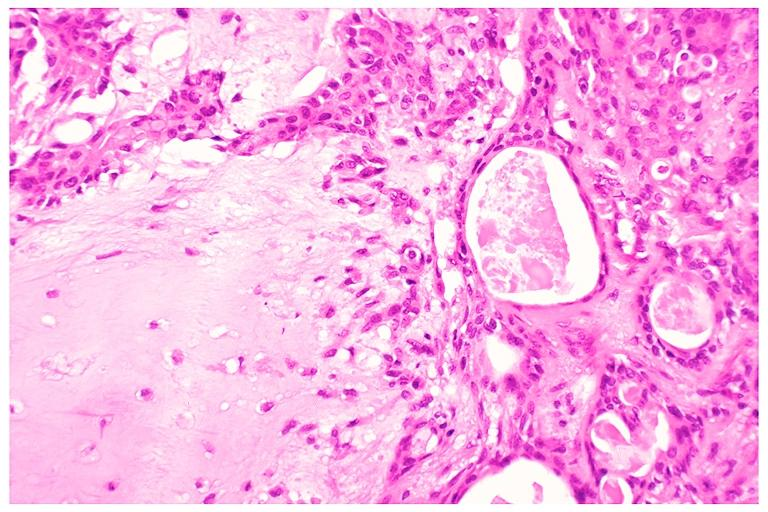s oral present?
Answer the question using a single word or phrase. Yes 